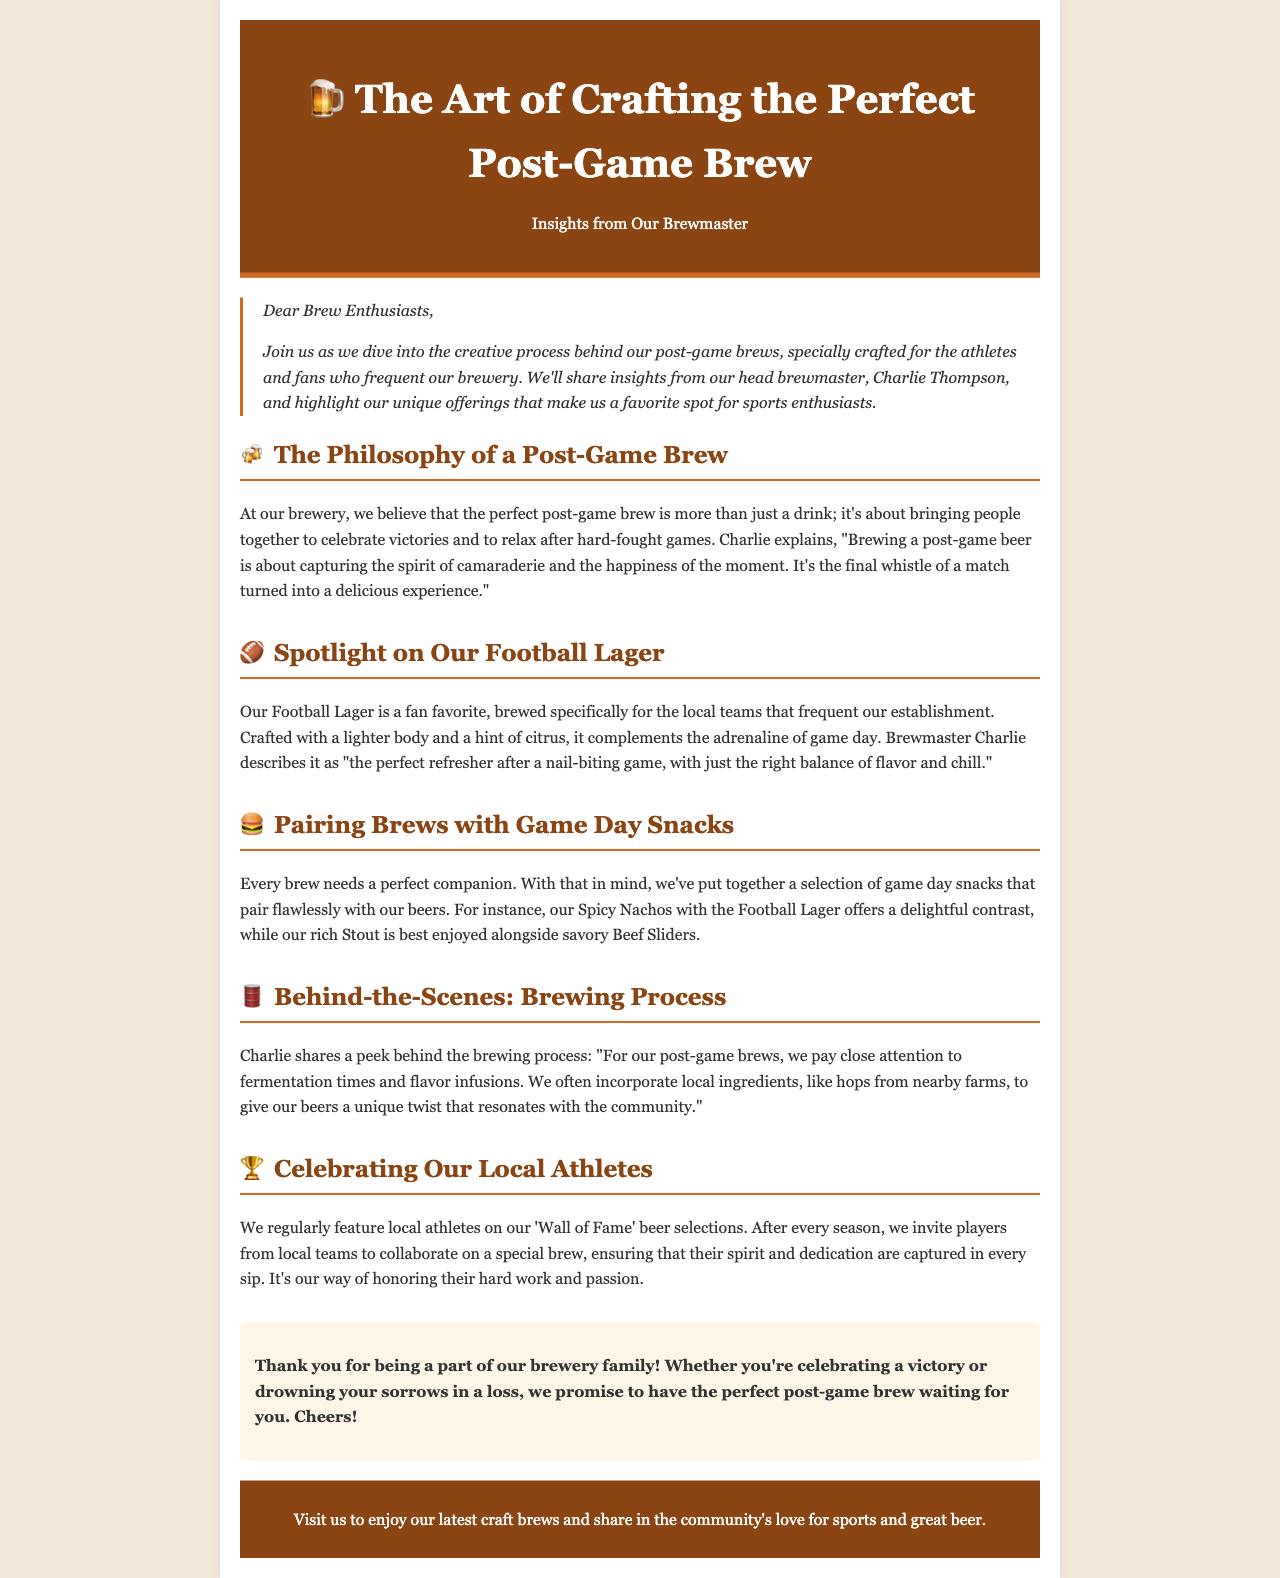What is the title of the newsletter? The title is prominently displayed at the top of the document, indicating the subject of the newsletter.
Answer: The Art of Crafting the Perfect Post-Game Brew Who is the head brewmaster mentioned in the newsletter? The name of the brewmaster is mentioned at the beginning of the main content, providing insight into the person behind the brewing.
Answer: Charlie Thompson What is the name of the featured beer for football fans? The specific beer created for football enthusiasts is highlighted in a section dedicated to it.
Answer: Football Lager What type of snacks are paired with the Football Lager? The document specifies a type of snack that complements the listed brew, emphasizing the pairing concept.
Answer: Spicy Nachos What local ingredient is mentioned as being used in the brewing process? A specific local ingredient is noted in the brewing process, highlighting the community connection.
Answer: Hops What is highlighted on the 'Wall of Fame' in the brewery? The section related to local athletes explains what is celebrated and recognized in the brewery's decor.
Answer: Local athletes How does the brewmaster describe the experience of brewing a post-game beer? Charlie's quote reflects the overall philosophy and enjoyment associated with crafting brews for the community.
Answer: Capturing the spirit of camaraderie What is the closing message to readers? The concluding remarks summarize the brewery's commitment to its patrons and the experience they provide.
Answer: Cheers! 